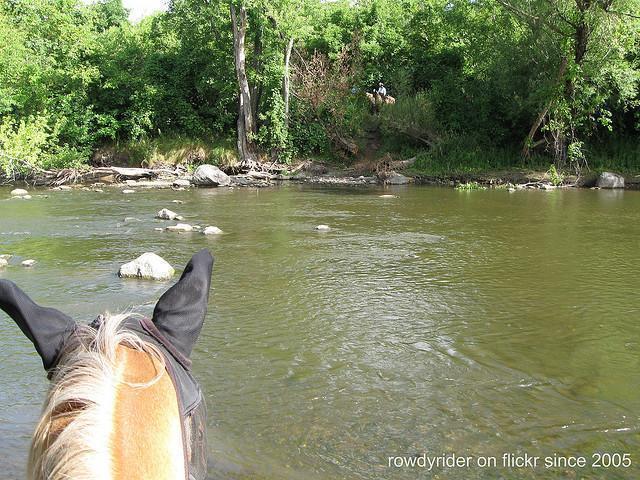What is the maximum speed of this type of animal in miles per hour?
From the following set of four choices, select the accurate answer to respond to the question.
Options: 15, 25, 40, 55. 55. 